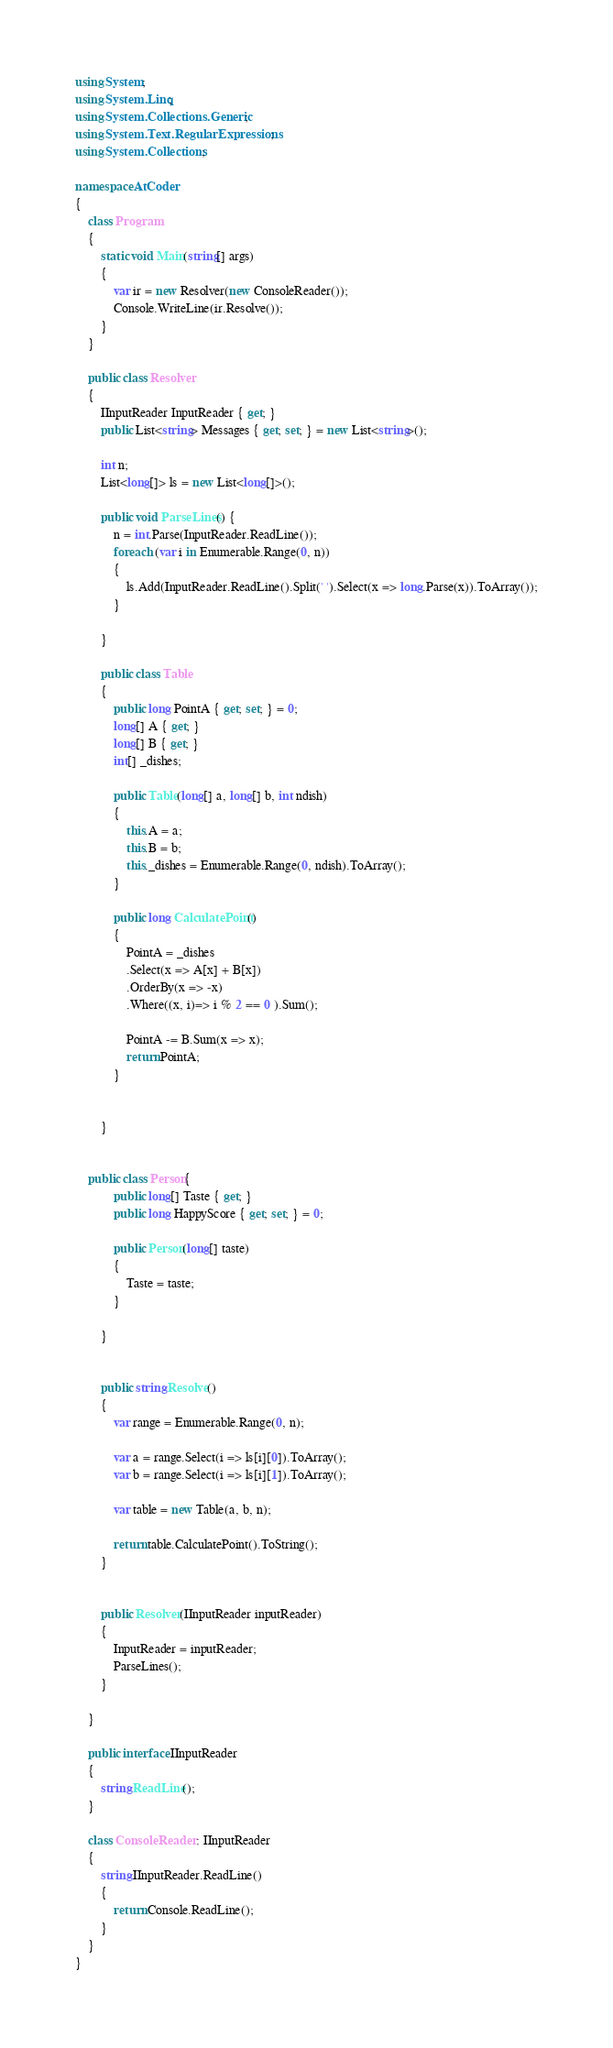<code> <loc_0><loc_0><loc_500><loc_500><_C#_>using System;
using System.Linq;
using System.Collections.Generic;
using System.Text.RegularExpressions;
using System.Collections;

namespace AtCoder
{
    class Program
    {
        static void Main(string[] args)
        {
            var ir = new Resolver(new ConsoleReader());
            Console.WriteLine(ir.Resolve());
        }
    }

    public class Resolver
    {
        IInputReader InputReader { get; }
        public List<string> Messages { get; set; } = new List<string>();

        int n;
        List<long[]> ls = new List<long[]>();

        public void ParseLines() {
            n = int.Parse(InputReader.ReadLine());
            foreach (var i in Enumerable.Range(0, n))
            {
                ls.Add(InputReader.ReadLine().Split(' ').Select(x => long.Parse(x)).ToArray());
            }

        }

        public class Table
        {
            public long PointA { get; set; } = 0;
            long[] A { get; }
            long[] B { get; }
            int[] _dishes;

            public Table(long[] a, long[] b, int ndish)
            {
                this.A = a;
                this.B = b;
                this._dishes = Enumerable.Range(0, ndish).ToArray();
            }

            public long CalculatePoint()
            {
                PointA = _dishes
                .Select(x => A[x] + B[x])
                .OrderBy(x => -x)
                .Where((x, i)=> i % 2 == 0 ).Sum();

                PointA -= B.Sum(x => x);
                return PointA;
            }


        }


    public class Person{
            public long[] Taste { get; }
            public long HappyScore { get; set; } = 0;

            public Person(long[] taste)
            {
                Taste = taste;
            }

        }


        public string Resolve()
        {
            var range = Enumerable.Range(0, n);

            var a = range.Select(i => ls[i][0]).ToArray();
            var b = range.Select(i => ls[i][1]).ToArray();

            var table = new Table(a, b, n);

            return table.CalculatePoint().ToString();
        }


        public Resolver(IInputReader inputReader)
        {
            InputReader = inputReader;
            ParseLines();
        }

    }

    public interface IInputReader
    {
        string ReadLine();
    }

    class ConsoleReader : IInputReader
    {
        string IInputReader.ReadLine()
        {
            return Console.ReadLine();
        }
    }
}
</code> 